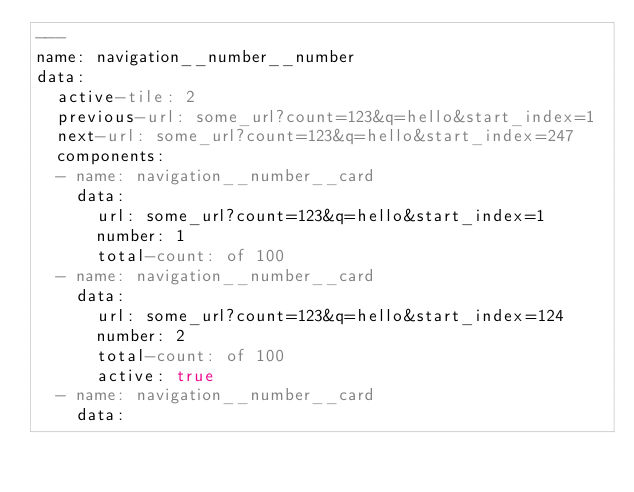<code> <loc_0><loc_0><loc_500><loc_500><_YAML_>---
name: navigation__number__number
data:
  active-tile: 2
  previous-url: some_url?count=123&q=hello&start_index=1
  next-url: some_url?count=123&q=hello&start_index=247
  components:
  - name: navigation__number__card
    data:
      url: some_url?count=123&q=hello&start_index=1
      number: 1
      total-count: of 100
  - name: navigation__number__card
    data:
      url: some_url?count=123&q=hello&start_index=124
      number: 2
      total-count: of 100
      active: true
  - name: navigation__number__card
    data:</code> 